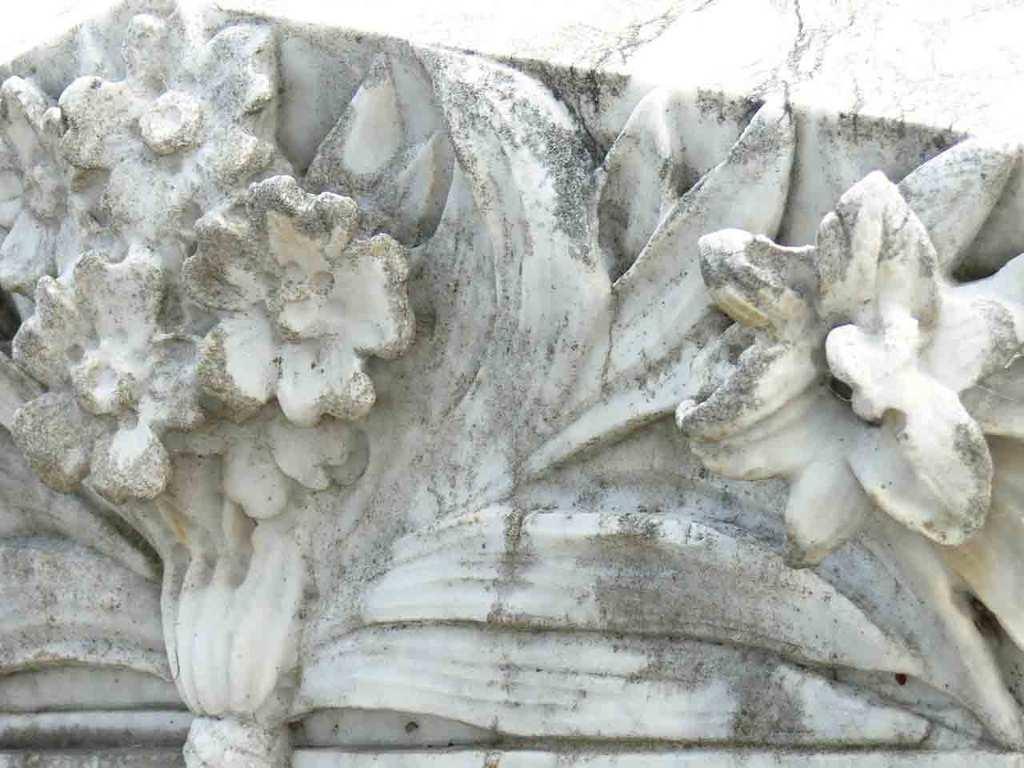How would you summarize this image in a sentence or two? There is a stone carving. 